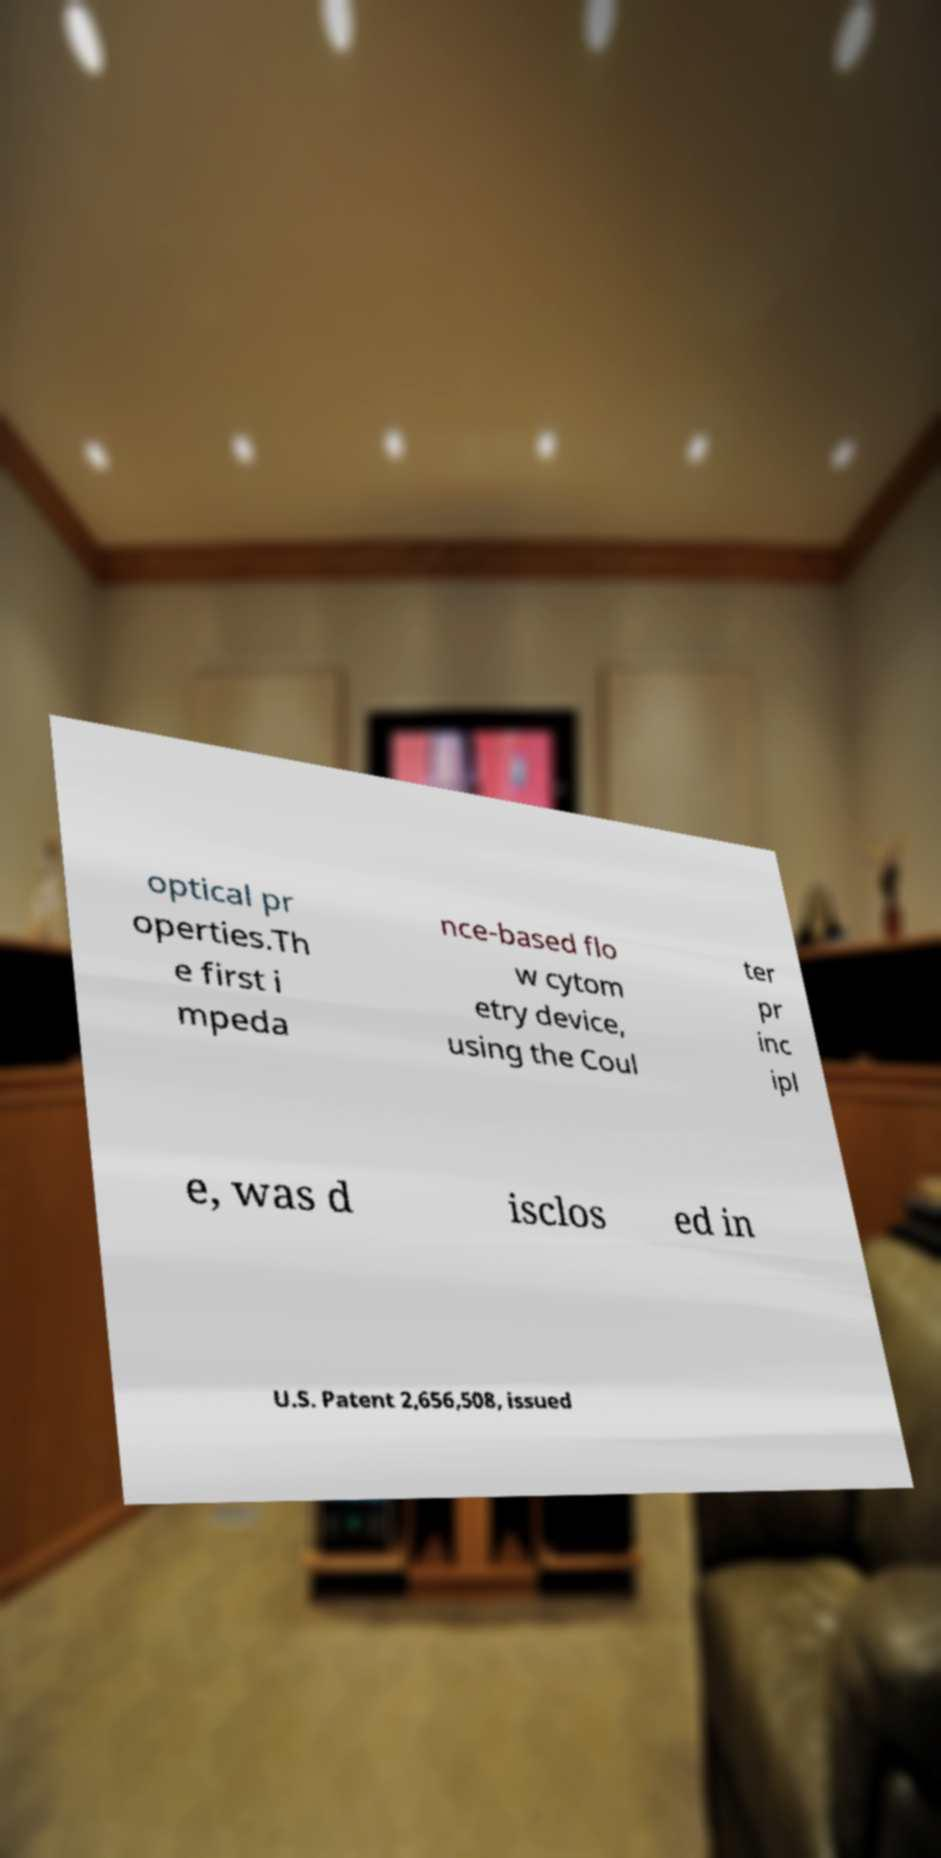Could you extract and type out the text from this image? optical pr operties.Th e first i mpeda nce-based flo w cytom etry device, using the Coul ter pr inc ipl e, was d isclos ed in U.S. Patent 2,656,508, issued 